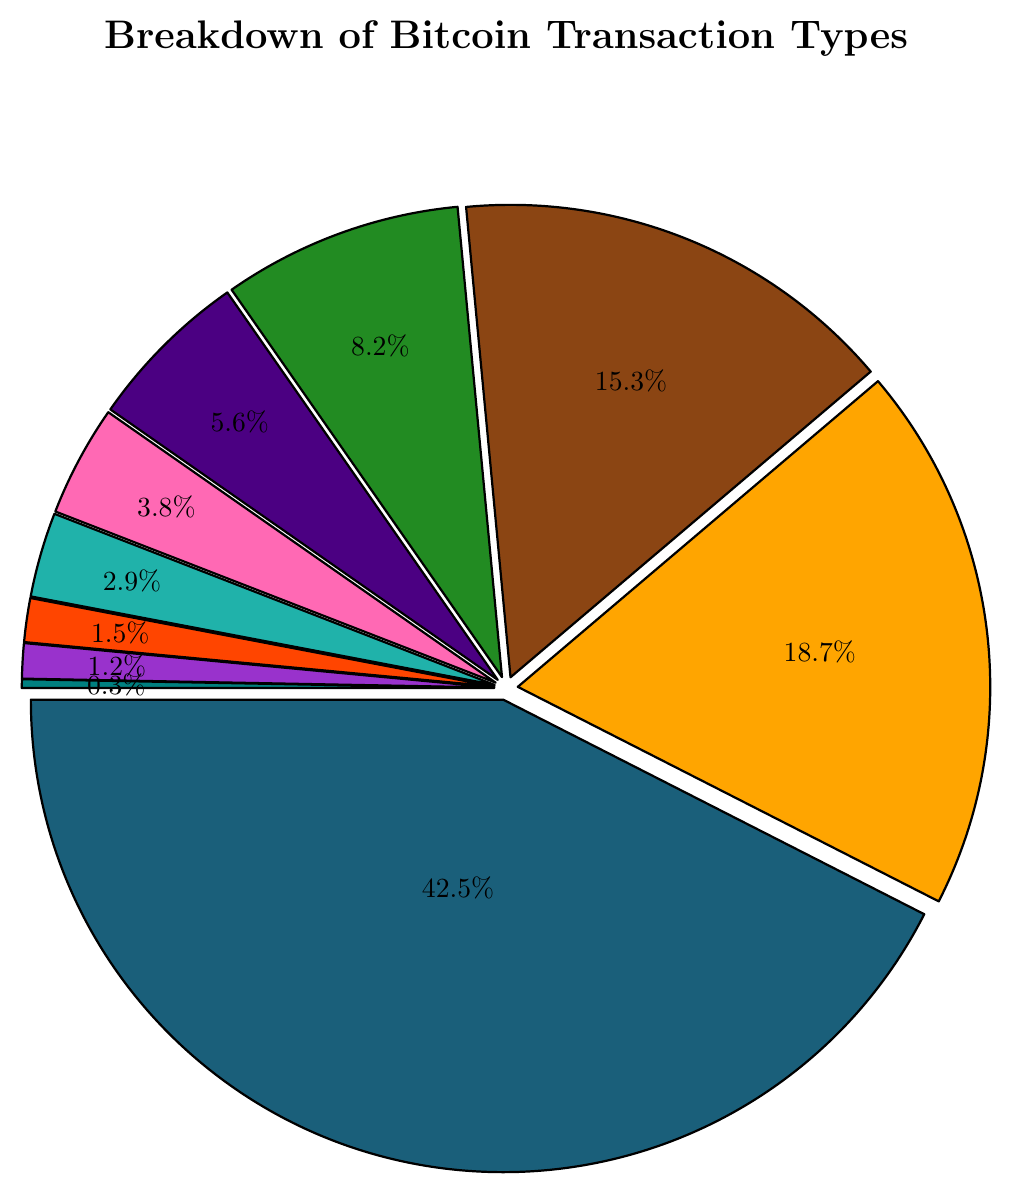What is the percentage of P2P Transfers? Look at the pie chart and find the segment labeled "P2P Transfers." The label shows a percentage of 42.5%.
Answer: 42.5% How many transaction types have a percentage greater than 10%? Identify the segments with percentages greater than 10%. These segments are P2P Transfers (42.5%), Exchange Deposits (18.7%), and Exchange Withdrawals (15.3%). There are three such transaction types.
Answer: 3 What's the total percentage of Exchange Deposits and Withdrawals combined? Add the percentage of Exchange Deposits (18.7%) to the percentage of Exchange Withdrawals (15.3%). The total is 18.7% + 15.3% = 34%.
Answer: 34% Which transaction type has the smallest percentage, and what is it? Find the segment with the smallest percentage. It is labeled "OP\_RETURN Data Storage" with a percentage of 0.3%.
Answer: OP_RETURN Data Storage, 0.3% What is the difference in percentage between Merchant Payments and Smart Contract Interactions? Subtract the percentage of Smart Contract Interactions (2.9%) from the percentage of Merchant Payments (8.2%). The difference is 8.2% - 2.9% = 5.3%.
Answer: 5.3% Which transaction type is represented by the green color? Identify the green segment in the pie chart. It corresponds to "Merchant Payments."
Answer: Merchant Payments What is the combined percentage of Mining Rewards and Mixing Services? Add the percentage of Mining Rewards (5.6%) to the percentage of Mixing Services (3.8%). The combined percentage is 5.6% + 3.8% = 9.4%.
Answer: 9.4% What is the sum of the percentages of the three smallest transaction types? Identify and sum the percentages of the three smallest transaction types: OP_RETURN Data Storage (0.3%), Multi-signature Transactions (1.2%), and Lightning Network Transactions (1.5%). The sum is 0.3% + 1.2% + 1.5% = 3%.
Answer: 3% Which transaction type has a percentage closest to 3%? Locate the segment with a percentage closest to 3%. The "Smart Contract Interactions" segment shows a percentage of 2.9%, which is closest to 3%.
Answer: Smart Contract Interactions 